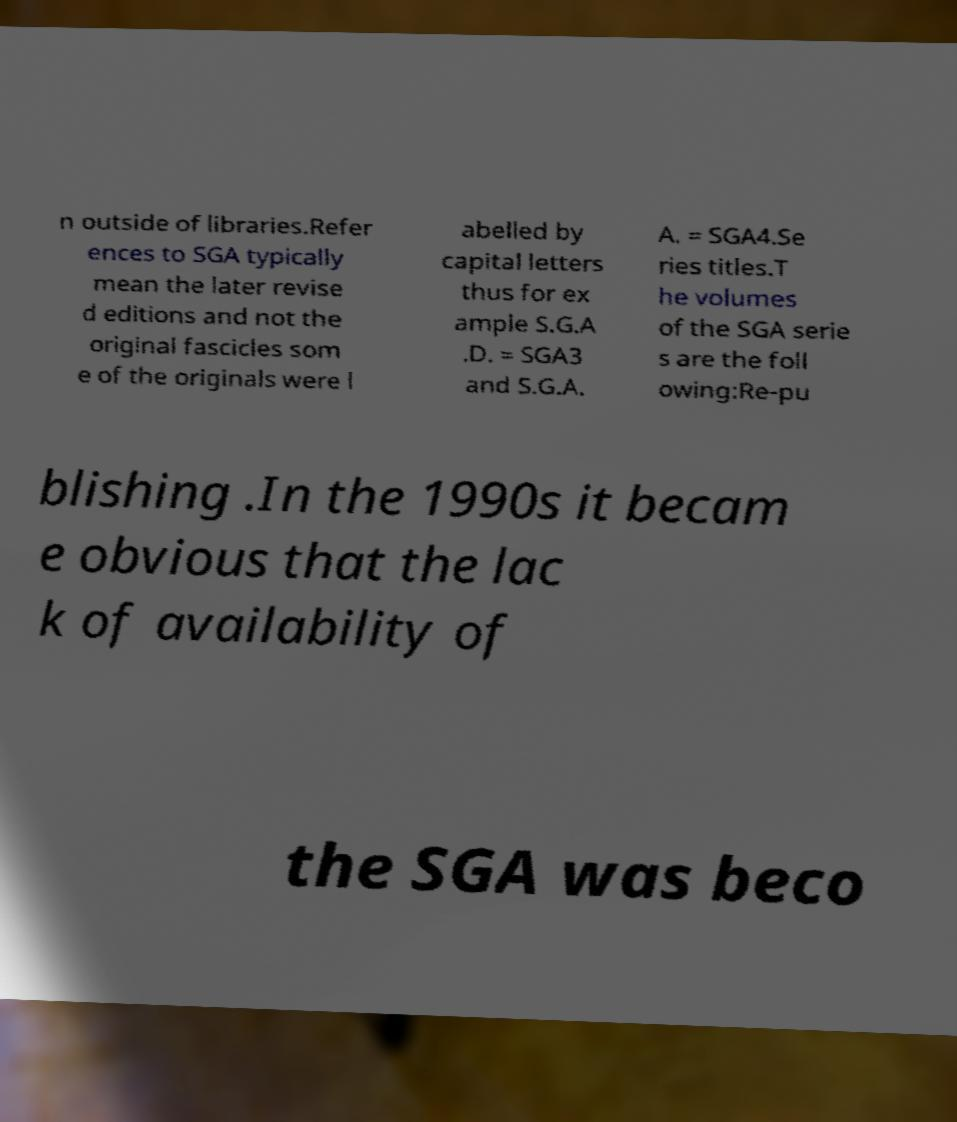Can you read and provide the text displayed in the image?This photo seems to have some interesting text. Can you extract and type it out for me? n outside of libraries.Refer ences to SGA typically mean the later revise d editions and not the original fascicles som e of the originals were l abelled by capital letters thus for ex ample S.G.A .D. = SGA3 and S.G.A. A. = SGA4.Se ries titles.T he volumes of the SGA serie s are the foll owing:Re-pu blishing .In the 1990s it becam e obvious that the lac k of availability of the SGA was beco 